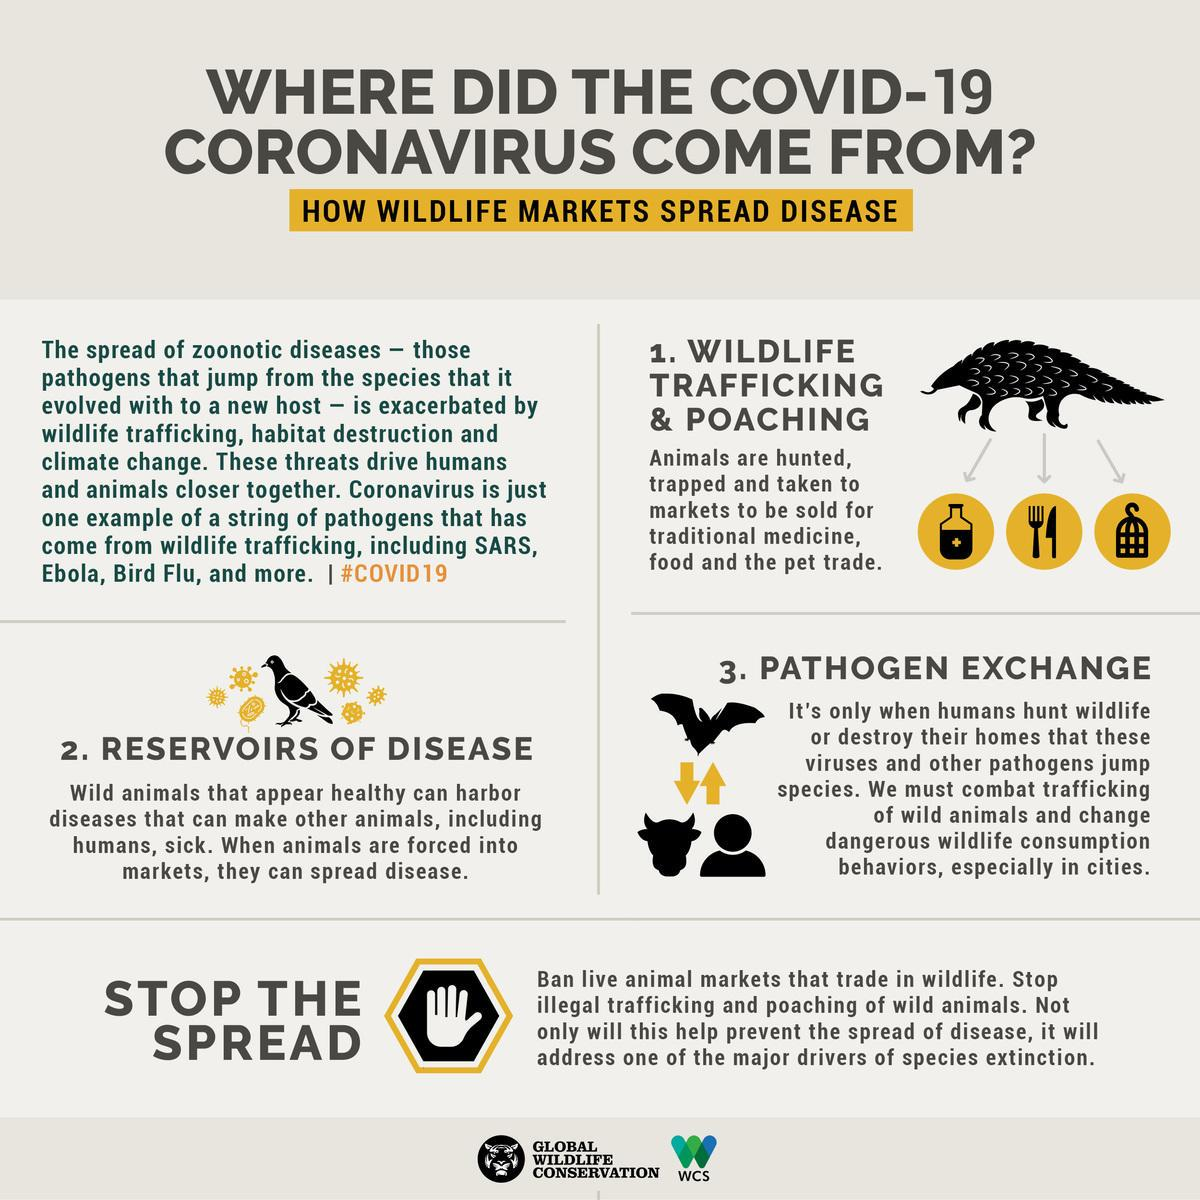Specify some key components in this picture. There are two animals depicted in this infographic. The infographic contains two birds. 